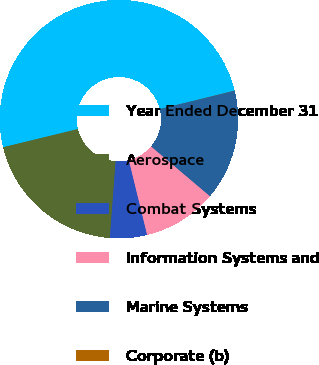Convert chart. <chart><loc_0><loc_0><loc_500><loc_500><pie_chart><fcel>Year Ended December 31<fcel>Aerospace<fcel>Combat Systems<fcel>Information Systems and<fcel>Marine Systems<fcel>Corporate (b)<nl><fcel>49.95%<fcel>20.0%<fcel>5.02%<fcel>10.01%<fcel>15.0%<fcel>0.02%<nl></chart> 